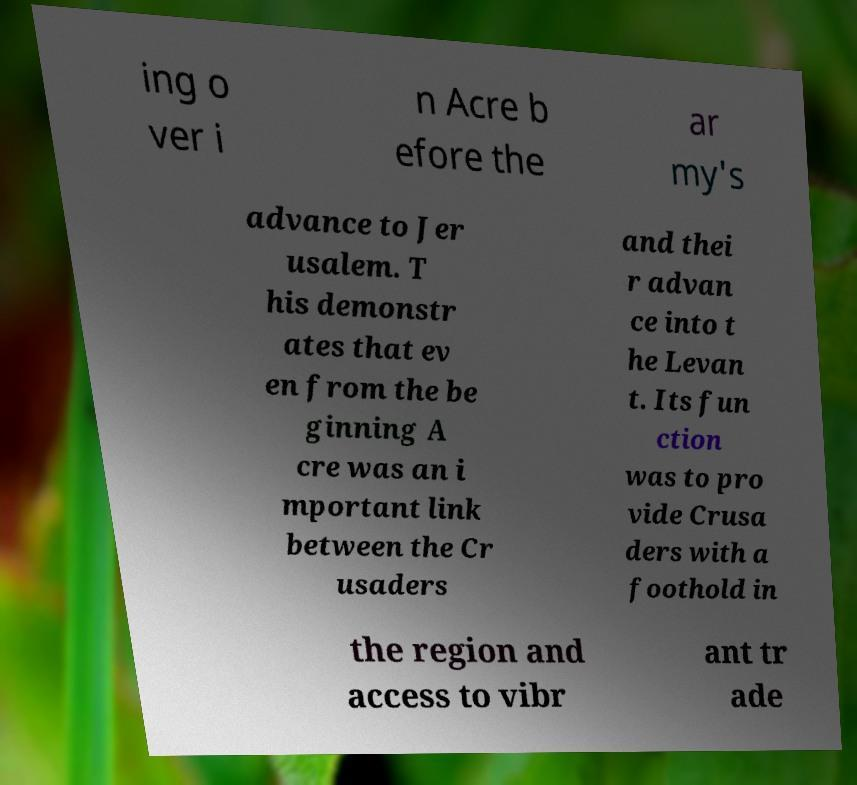I need the written content from this picture converted into text. Can you do that? ing o ver i n Acre b efore the ar my's advance to Jer usalem. T his demonstr ates that ev en from the be ginning A cre was an i mportant link between the Cr usaders and thei r advan ce into t he Levan t. Its fun ction was to pro vide Crusa ders with a foothold in the region and access to vibr ant tr ade 